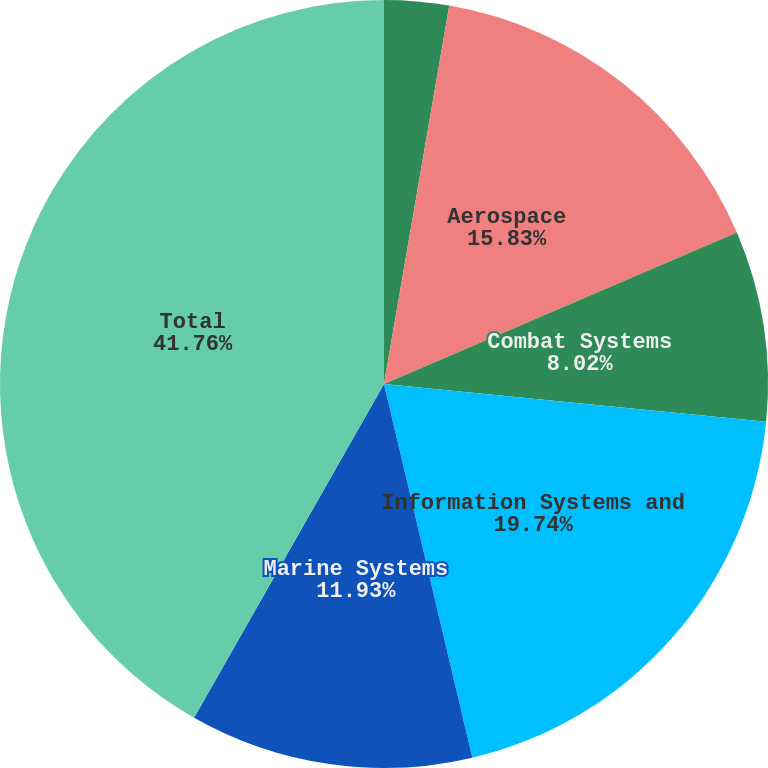Convert chart. <chart><loc_0><loc_0><loc_500><loc_500><pie_chart><fcel>Year Ended December 31<fcel>Aerospace<fcel>Combat Systems<fcel>Information Systems and<fcel>Marine Systems<fcel>Total<nl><fcel>2.72%<fcel>15.83%<fcel>8.02%<fcel>19.74%<fcel>11.93%<fcel>41.77%<nl></chart> 